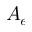Convert formula to latex. <formula><loc_0><loc_0><loc_500><loc_500>A _ { e }</formula> 